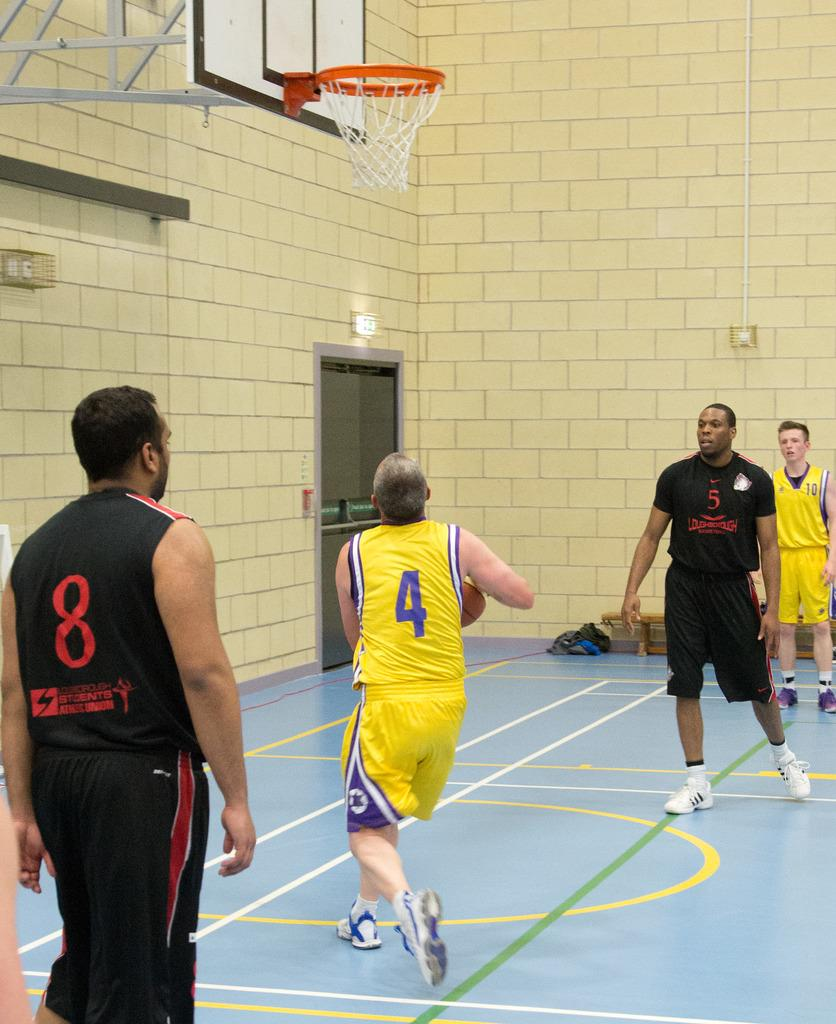Provide a one-sentence caption for the provided image. A man with the number 4 jersey attempt to shoot a ball in the hoop. 